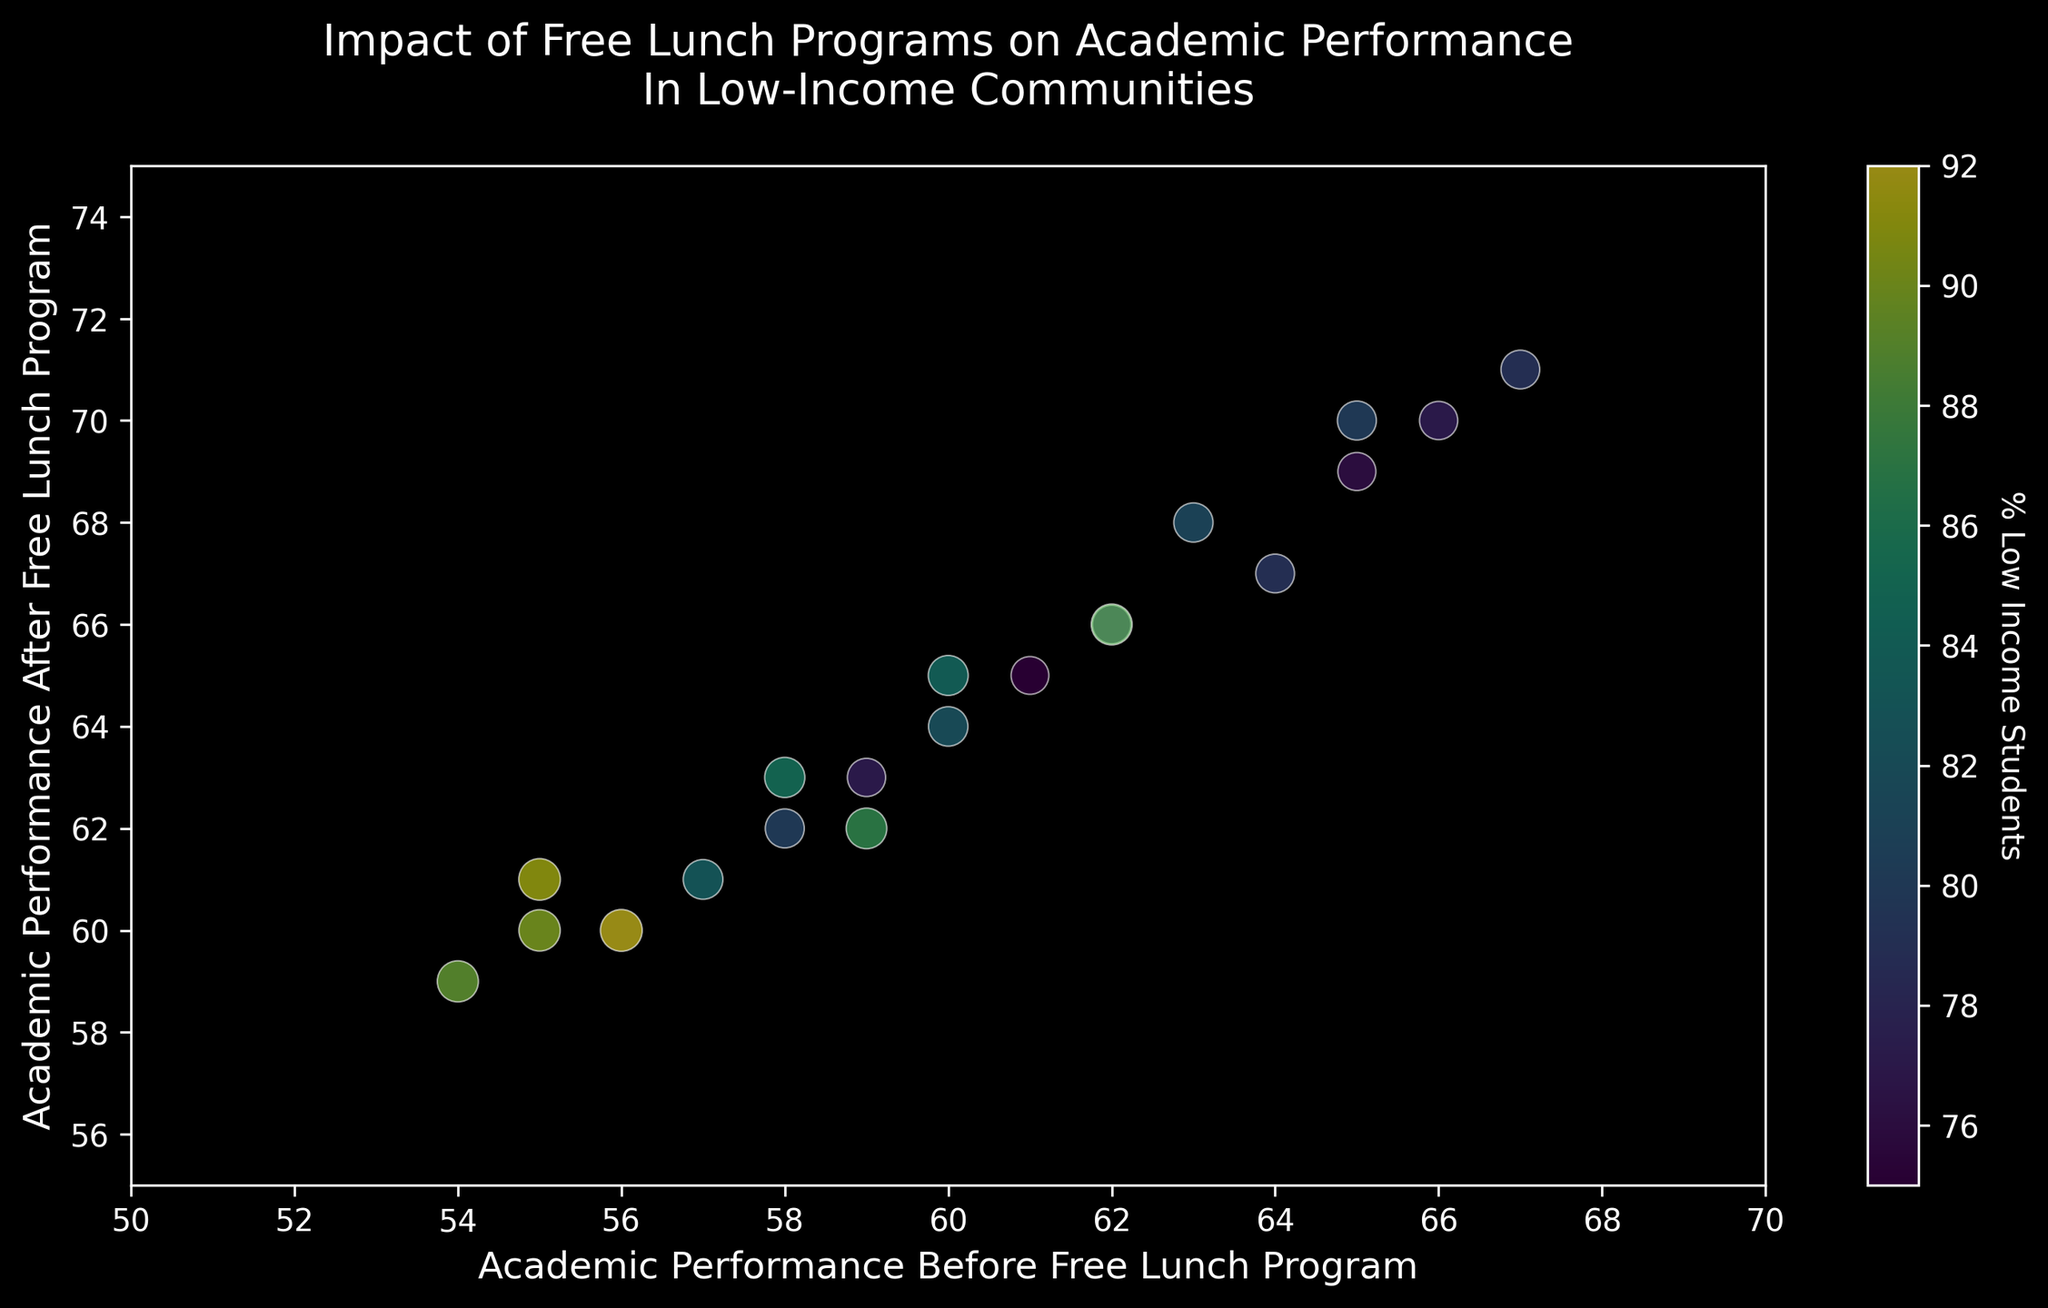What is the difference in academic performance before and after the free lunch program for the school with the highest percentage of low-income students? First, find the school with the highest percentage of low-income students (92%). Then look at its academic performance before (56) and after (60) the free lunch program. Calculate the difference: 60 - 56 = 4
Answer: 4 Which school showed the highest improvement in academic performance after the implementation of the free lunch program? To find the highest improvement, calculate the difference in performance for each school and identify the maximum value. The largest improvement is 6, observed in the school with a performance increase from 66 to 71
Answer: School ID 120 Are there any schools where the academic performance did not improve after the free lunch program? To answer this, check for any schools where the "academic performance after" value is equal to or lower than the "academic performance before" value. There are no such schools; all show some improvement
Answer: No Which school had the largest academic performance before the implementation of the free lunch program? To find this, look at the "academic performance before" values and identify the highest one, which is 67 for school ID 120
Answer: School ID 120 What is the average academic performance improvement across all schools? Calculate the improvement for each school, sum them up, and then divide by the number of schools. The improvements are (70-65), (63-58), (66-62), (64-60), (60-55), (62-59), (65-61), (70-66), (67-64), (61-57), (60-56), (68-63), (59-54), (69-65), (65-60), (62-58), (66-62), (61-55), (63-59), (71-67), giving a total of 88. Divide by the number of schools (20), yielding 4.4
Answer: 4.4 By how many points did the academic performance improve for the school with 80% low-income students? Identify the school with 80% low-income students, and find the academic performance before and after: 65 and 70. Calculate the difference: 70 - 65 = 5
Answer: 5 Does a higher percentage of low-income students correlate with a larger improvement in academic performance? Review the scatter plot to look for any visible trend between the size of the markers (which relate to low-income percentage) and the amount of performance improvement. There is no clear trend from the given visual cues
Answer: No clear correlation What is the median academic performance after the implementation of the free lunch program? List all "academic performance after" values, order them and find the middle value. Sorted: 59, 60, 60, 61, 61, 62, 63, 63, 65, 65, 66, 66, 67, 68, 69, 70, 70, 71. The median of these 20 values is the average of the 10th and 11th values (65+66)/2 = 65.5
Answer: 65.5 Are most schools with a greater than 85% low-income student percentage clustered in a specific range of academic performance improvement? Identify schools with more than 85% low-income (IDs: 102, 105, 106, 111, 113, 117, 118). Then observe their improvement range. Improvements are: 5, 6, 3, 4, 5, 4, 6. They are clustered mainly between 3 to 6 points
Answer: 3 to 6 points 